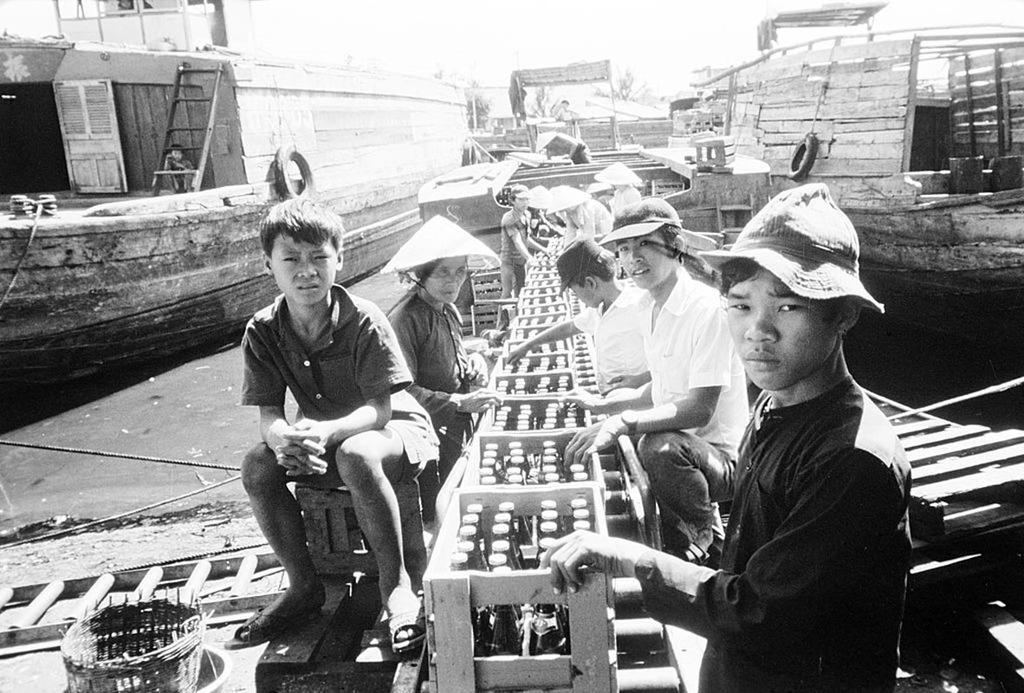What type of vehicles are in the image? There are boats in the image. What can be seen inside the wooden boxes in the image? There are bottles in wooden boxes in the image. What type of headwear are the people wearing in the image? There are people wearing caps in the image. What type of natural elements can be seen in the background of the image? There are plants visible in the background of the image. How many crowns are visible on the people's heads in the image? There are no crowns visible on the people's heads in the image; they are wearing caps. 